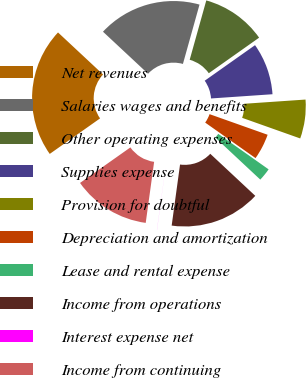Convert chart to OTSL. <chart><loc_0><loc_0><loc_500><loc_500><pie_chart><fcel>Net revenues<fcel>Salaries wages and benefits<fcel>Other operating expenses<fcel>Supplies expense<fcel>Provision for doubtful<fcel>Depreciation and amortization<fcel>Lease and rental expense<fcel>Income from operations<fcel>Interest expense net<fcel>Income from continuing<nl><fcel>21.73%<fcel>17.39%<fcel>10.87%<fcel>8.7%<fcel>6.52%<fcel>4.35%<fcel>2.18%<fcel>15.21%<fcel>0.01%<fcel>13.04%<nl></chart> 